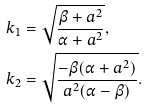<formula> <loc_0><loc_0><loc_500><loc_500>k _ { 1 } & = \sqrt { \frac { \beta + a ^ { 2 } } { \alpha + a ^ { 2 } } } , \\ k _ { 2 } & = \sqrt { \frac { - \beta ( \alpha + a ^ { 2 } ) } { a ^ { 2 } ( \alpha - \beta ) } } .</formula> 